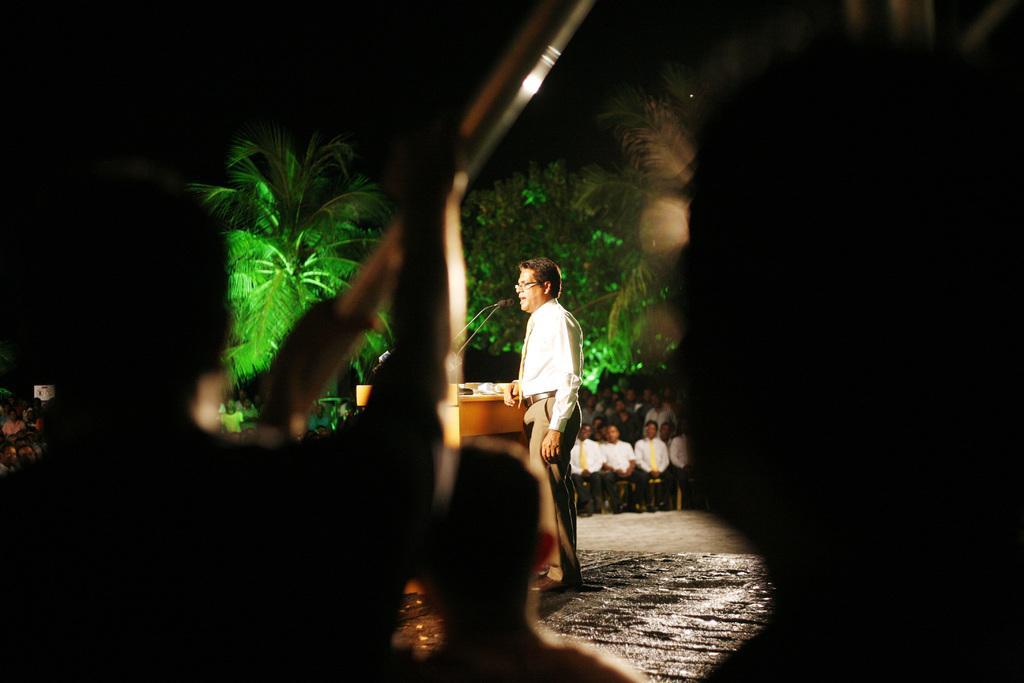In one or two sentences, can you explain what this image depicts? In this image, I can see a person standing. This looks like a podium with the miles. I can see few people sitting. These are the trees. In front of the image, I can see few people. The background looks dark. 